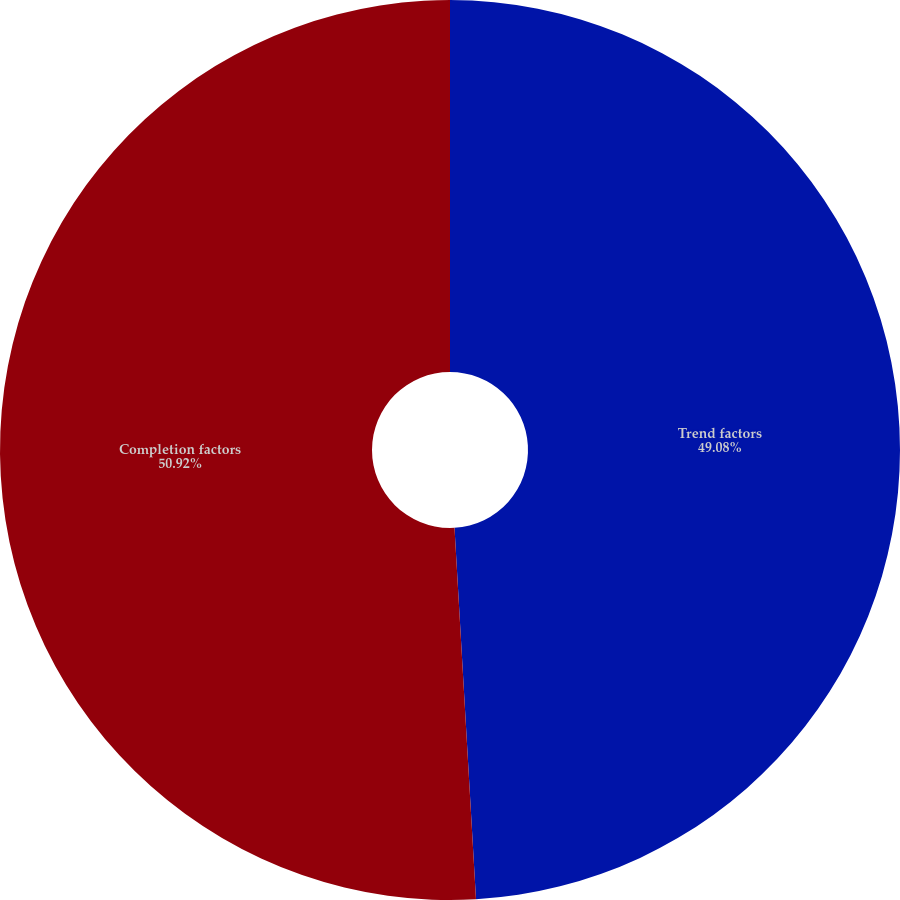Convert chart. <chart><loc_0><loc_0><loc_500><loc_500><pie_chart><fcel>Trend factors<fcel>Completion factors<nl><fcel>49.08%<fcel>50.92%<nl></chart> 